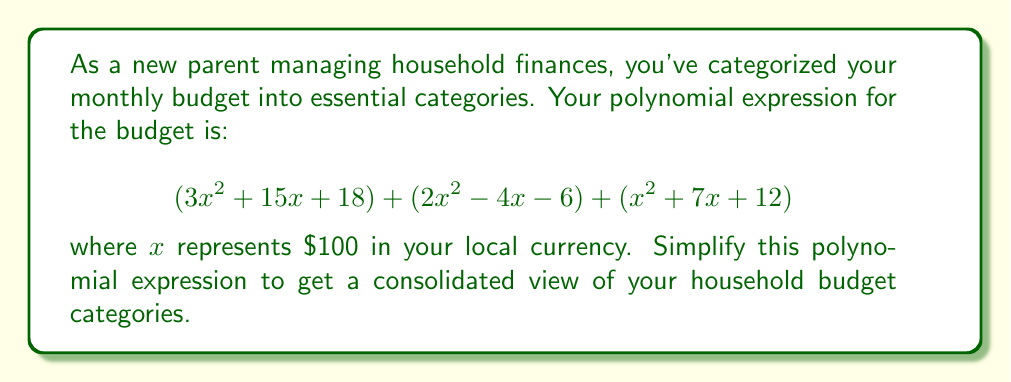Teach me how to tackle this problem. Let's simplify this polynomial expression step-by-step:

1) First, we need to combine like terms. We have three terms with $x^2$, three terms with $x$, and three constant terms.

2) Combining $x^2$ terms:
   $3x^2 + 2x^2 + x^2 = 6x^2$

3) Combining $x$ terms:
   $15x + (-4x) + 7x = 18x$

4) Combining constant terms:
   $18 + (-6) + 12 = 24$

5) Now we can write our simplified polynomial:

   $$6x^2 + 18x + 24$$

6) This polynomial can be factored further. Let's check if it has a common factor:
   
   $6x^2 + 18x + 24 = 6(x^2 + 3x + 4)$

7) The quadratic expression inside the parentheses $(x^2 + 3x + 4)$ cannot be factored further as it doesn't have real roots.

Thus, the final simplified form of the budget polynomial is $6(x^2 + 3x + 4)$.
Answer: $6(x^2 + 3x + 4)$ 